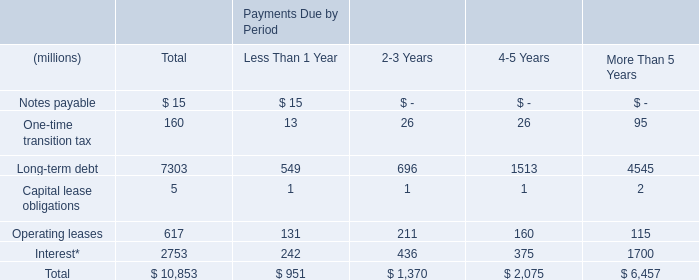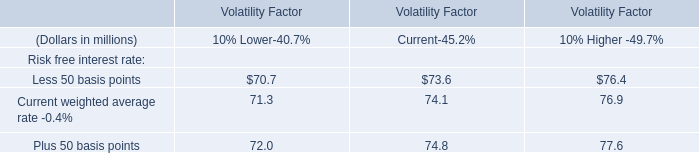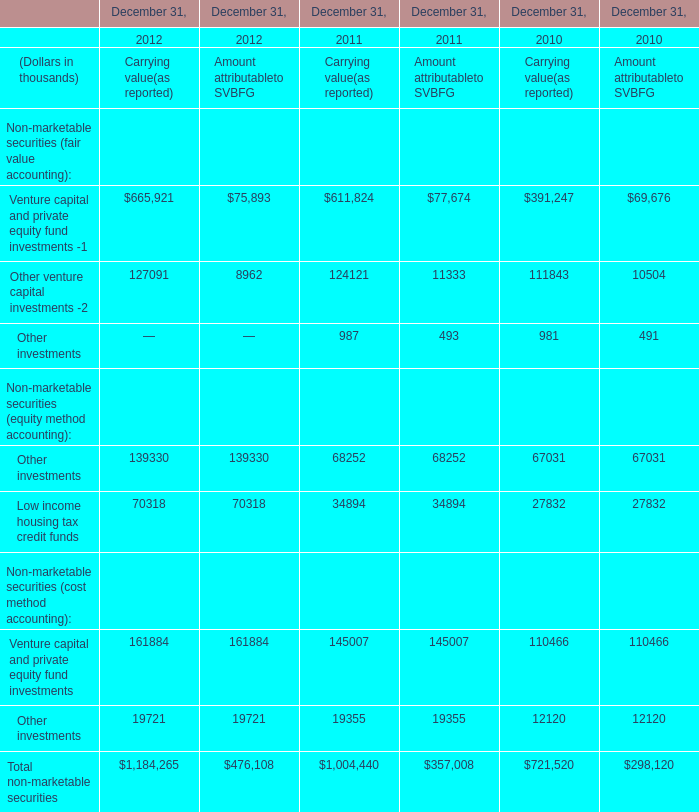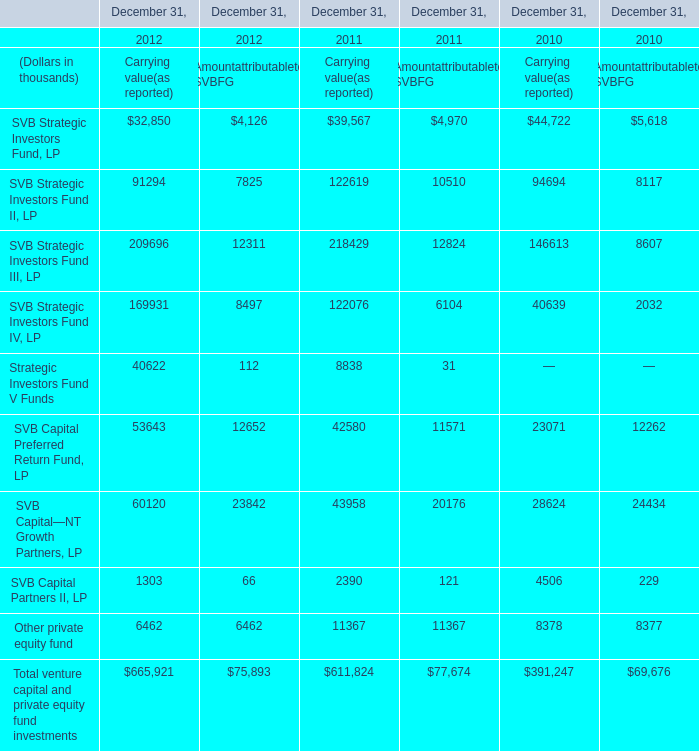What was the total amount of the Low income housing tax credit funds in the years where Other venture capital investments -2 greater than 0? (in thousand) 
Computations: (((((70318 + 70318) + 34894) + 34894) + 27832) + 27832)
Answer: 266088.0. 